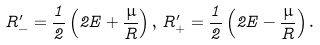<formula> <loc_0><loc_0><loc_500><loc_500>R ^ { \prime } _ { - } = \frac { 1 } { 2 } \left ( 2 E + \frac { \mu } { R } \right ) , \, R ^ { \prime } _ { + } = \frac { 1 } { 2 } \left ( 2 E - \frac { \mu } { R } \right ) .</formula> 